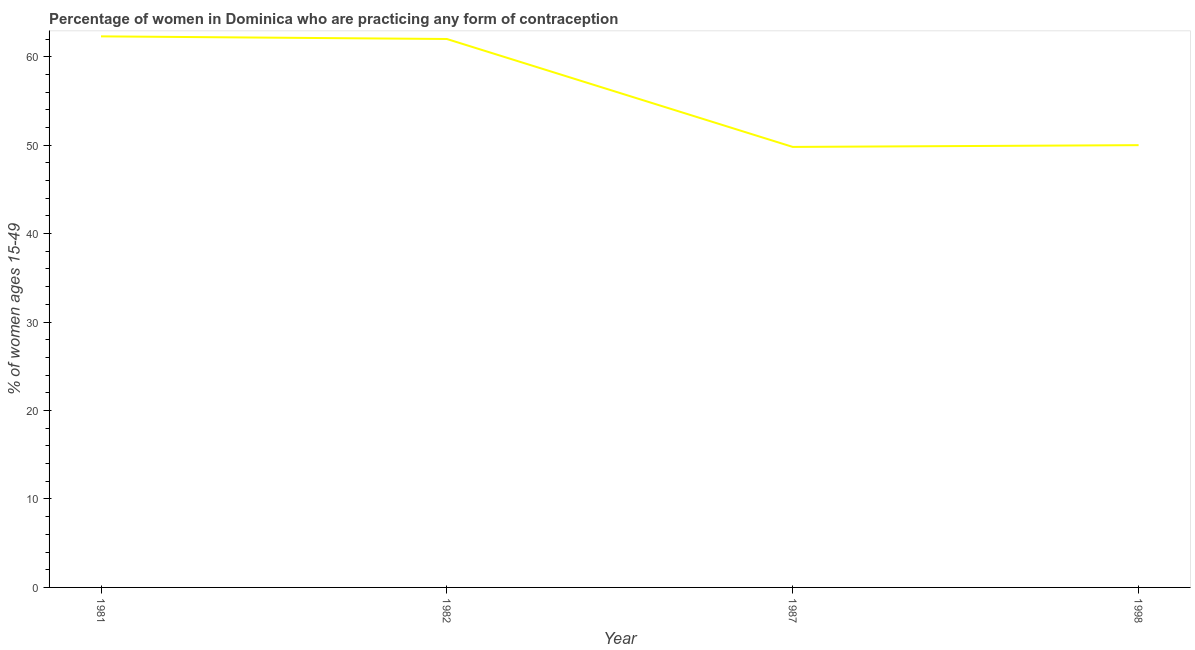What is the contraceptive prevalence in 1987?
Your answer should be compact. 49.8. Across all years, what is the maximum contraceptive prevalence?
Your response must be concise. 62.3. Across all years, what is the minimum contraceptive prevalence?
Make the answer very short. 49.8. In which year was the contraceptive prevalence maximum?
Your answer should be compact. 1981. What is the sum of the contraceptive prevalence?
Ensure brevity in your answer.  224.1. What is the difference between the contraceptive prevalence in 1981 and 1982?
Give a very brief answer. 0.3. What is the average contraceptive prevalence per year?
Offer a very short reply. 56.02. What is the median contraceptive prevalence?
Offer a very short reply. 56. In how many years, is the contraceptive prevalence greater than 26 %?
Make the answer very short. 4. Do a majority of the years between 1982 and 1987 (inclusive) have contraceptive prevalence greater than 50 %?
Ensure brevity in your answer.  No. What is the ratio of the contraceptive prevalence in 1981 to that in 1998?
Make the answer very short. 1.25. Is the contraceptive prevalence in 1982 less than that in 1987?
Your response must be concise. No. What is the difference between the highest and the second highest contraceptive prevalence?
Provide a succinct answer. 0.3. Is the sum of the contraceptive prevalence in 1981 and 1998 greater than the maximum contraceptive prevalence across all years?
Your answer should be compact. Yes. What is the difference between the highest and the lowest contraceptive prevalence?
Your response must be concise. 12.5. In how many years, is the contraceptive prevalence greater than the average contraceptive prevalence taken over all years?
Provide a short and direct response. 2. How many lines are there?
Provide a succinct answer. 1. How many years are there in the graph?
Offer a very short reply. 4. Does the graph contain any zero values?
Provide a short and direct response. No. What is the title of the graph?
Your answer should be very brief. Percentage of women in Dominica who are practicing any form of contraception. What is the label or title of the Y-axis?
Your answer should be very brief. % of women ages 15-49. What is the % of women ages 15-49 of 1981?
Make the answer very short. 62.3. What is the % of women ages 15-49 of 1987?
Make the answer very short. 49.8. What is the difference between the % of women ages 15-49 in 1981 and 1987?
Offer a very short reply. 12.5. What is the difference between the % of women ages 15-49 in 1981 and 1998?
Make the answer very short. 12.3. What is the difference between the % of women ages 15-49 in 1982 and 1987?
Ensure brevity in your answer.  12.2. What is the difference between the % of women ages 15-49 in 1987 and 1998?
Keep it short and to the point. -0.2. What is the ratio of the % of women ages 15-49 in 1981 to that in 1987?
Your answer should be very brief. 1.25. What is the ratio of the % of women ages 15-49 in 1981 to that in 1998?
Provide a succinct answer. 1.25. What is the ratio of the % of women ages 15-49 in 1982 to that in 1987?
Offer a very short reply. 1.25. What is the ratio of the % of women ages 15-49 in 1982 to that in 1998?
Keep it short and to the point. 1.24. 